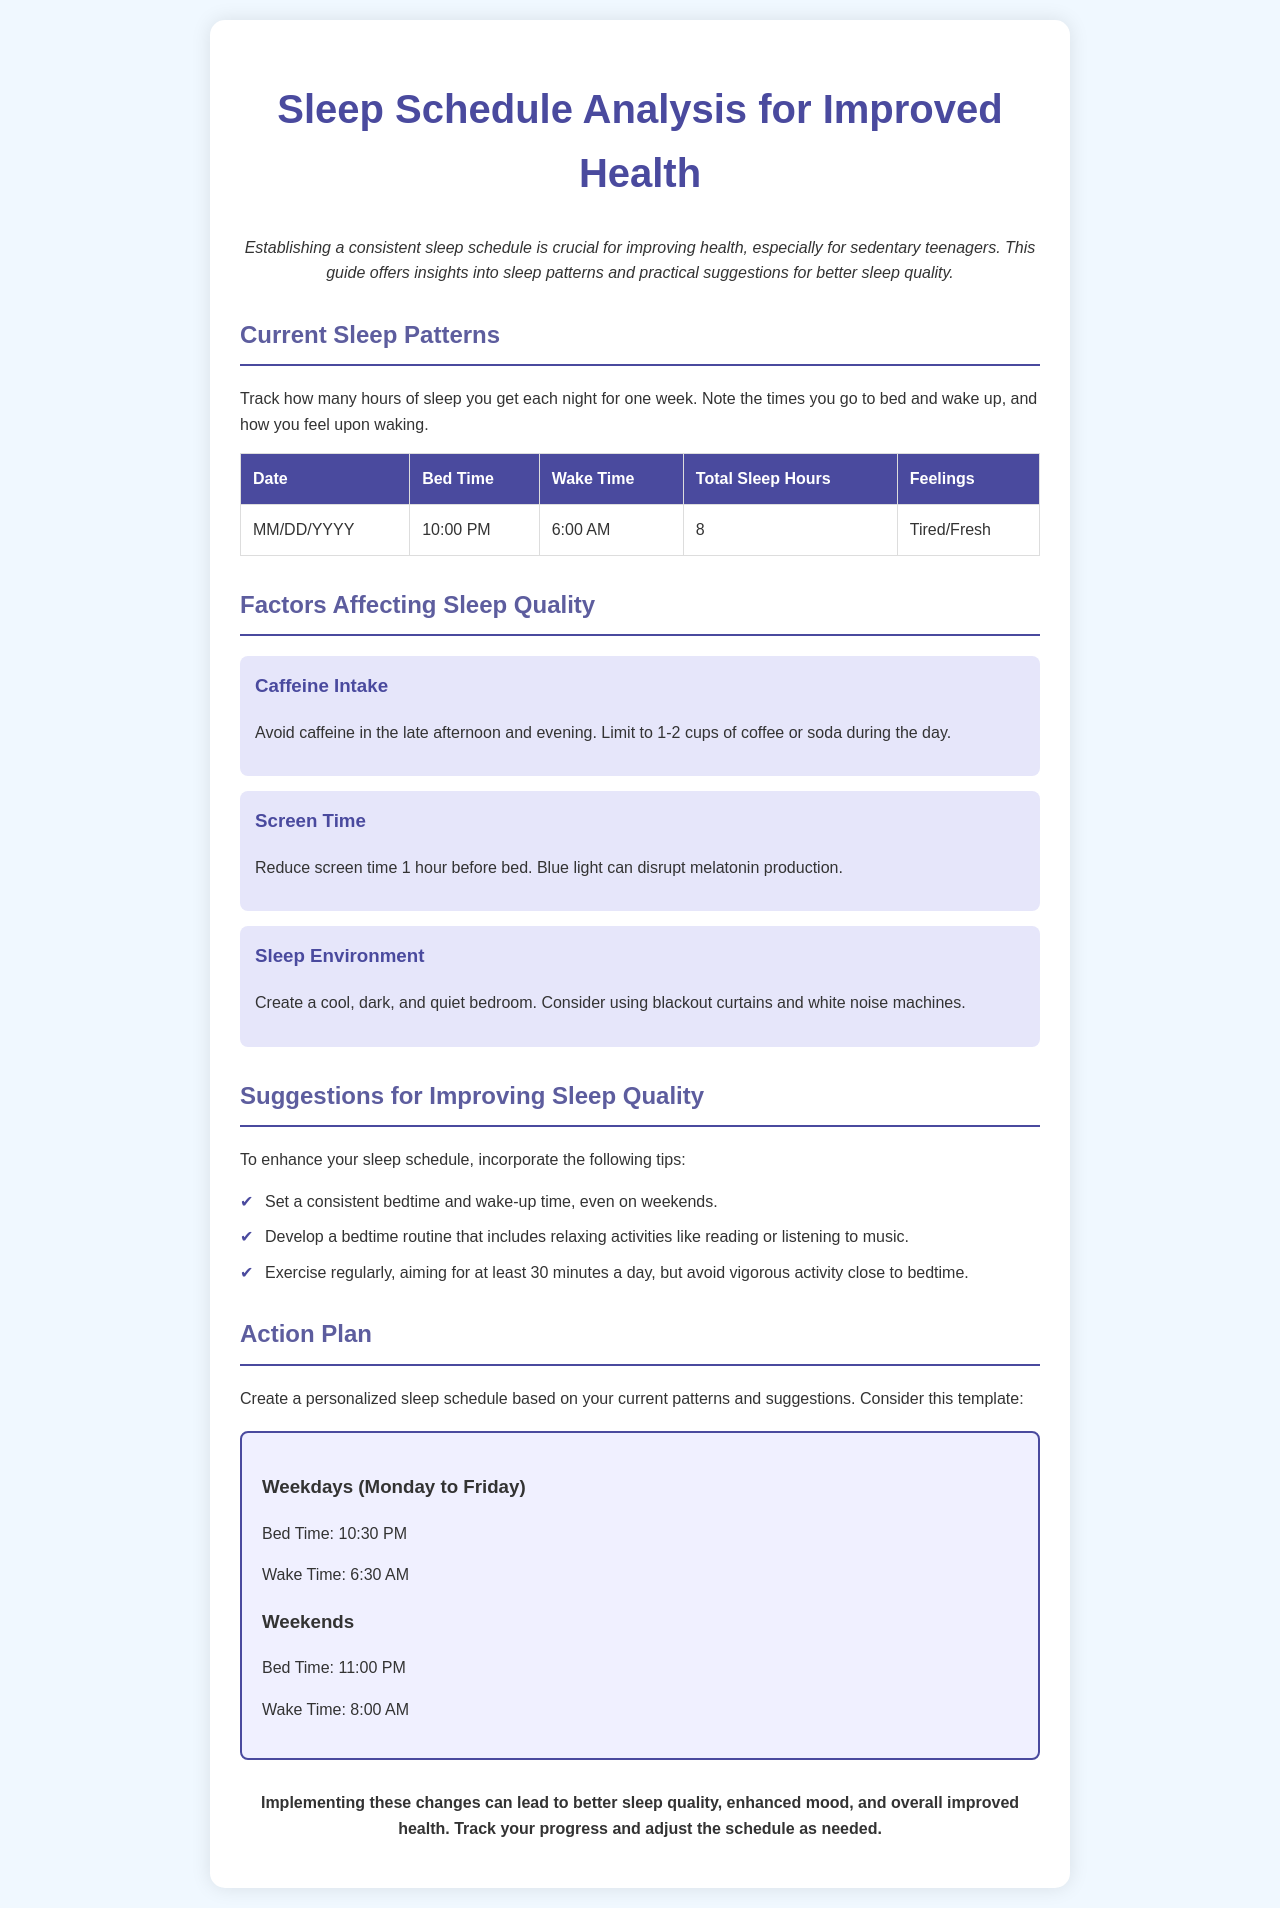What is the title of the document? The title is displayed prominently at the top of the document.
Answer: Sleep Schedule Analysis for Improved Health What time should you wake up on weekdays? The schedule section specifies wake-up times for weekdays.
Answer: 6:30 AM How many total sleep hours were tracked in the example table? The table shows an example of sleep hours recorded.
Answer: 8 What is one factor affecting sleep quality? The document lists various factors that can impact sleep.
Answer: Caffeine Intake What is suggested to reduce before bed? The suggestions include reducing specific activities to improve sleep.
Answer: Screen Time What is the bedtime on weekends in the action plan? The action plan outlines suggested bedtimes for weekends.
Answer: 11:00 PM Which activity is recommended to enhance sleep quality? The suggestions include various activities to improve sleep.
Answer: Exercise regularly What should be done to create a better sleep environment? The document explains how to improve the sleeping environment.
Answer: Create a cool, dark, and quiet bedroom How should someone feel upon waking, according to the table? The feelings recorded in the table indicate how one might feel after waking.
Answer: Tired/Fresh 